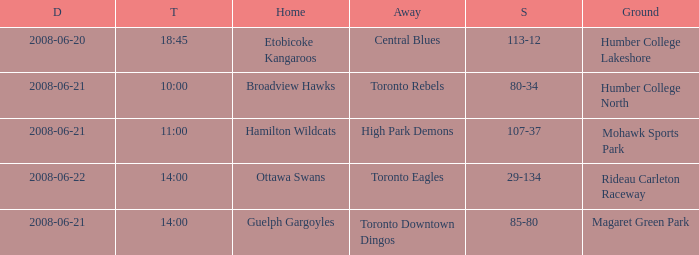What is the Away with a Ground that is humber college lakeshore? Central Blues. 